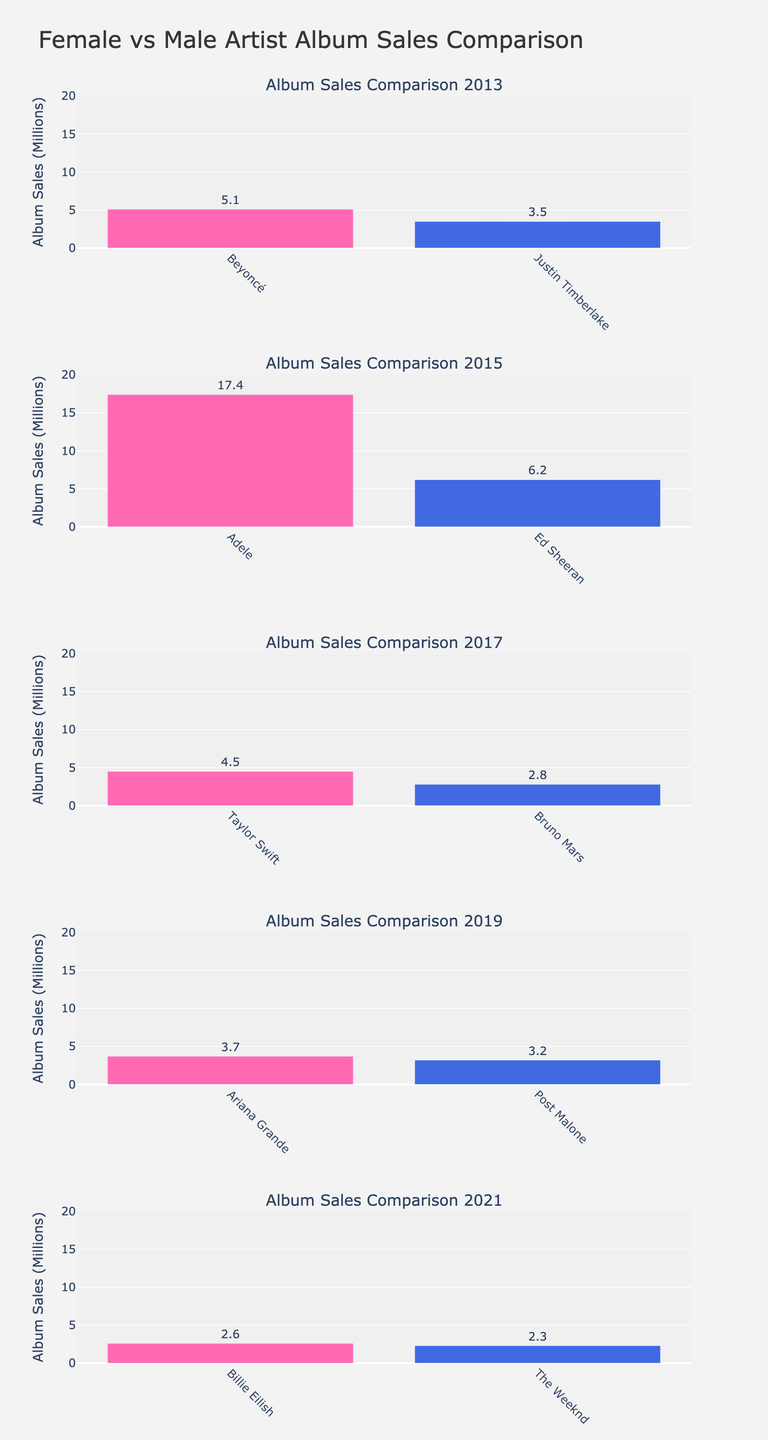Which show has the highest rating in season 1? Look at each subplot representing the different shows and focus on the ratings for season 1. Compare the ratings: "Law & Order" (7.2), "NYPD Blue" (8.0), "The Wire" (8.6), "Hill Street Blues" (7.9), "Blue Bloods" (7.5). "The Wire" has the highest rating in season 1.
Answer: The Wire How does the rating of "Law & Order" change from season 1 to season 20? In the "Law & Order" subplot, check the ratings for season 1 (7.2) and season 20 (7.9) and calculate the difference. The rating increases from 7.2 to 7.9, showing a change of +0.7.
Answer: +0.7 Which show has the most consistent rating across the plotted seasons? Examine the plots and look for the show with the least fluctuation in its ratings. "Blue Bloods" ratings vary between 7.5 and 7.8, while other shows have larger variations.
Answer: Blue Bloods What is the average rating for "NYPD Blue" across the seasons shown? Add the ratings for "NYPD Blue" across all plotted seasons: 8.0 (S1), 8.4 (S4), 8.2 (S8), 7.8 (S12). Then divide by the number of seasons (4): (8.0 + 8.4 + 8.2 + 7.8) / 4 = 8.1.
Answer: 8.1 Which show witnessed the highest peak rating among all the shows, and what was the rating? Look for the highest data point in all subplots. "The Wire" reached a peak rating of 9.2 in season 5.
Answer: The Wire, 9.2 Between "Hill Street Blues" and "Blue Bloods," which show had a higher rating in their respective 5th seasons? Compare the ratings in season 5 for "Hill Street Blues" (8.5) and "Blue Bloods" (7.8). "Hill Street Blues" has a higher rating.
Answer: Hill Street Blues What is the title of the figure? The title is centered at the top of the figure. It reads "Viewer Ratings for Top 5 Police-Themed TV Shows."
Answer: Viewer Ratings for Top 5 Police-Themed TV Shows In which season did "The Wire" experience its lowest rating, and what was the rating? Check the "The Wire" subplot and identify the lowest rating among all seasons: 8.6 in season 1.
Answer: Season 1, 8.6 Which two shows have ratings plotted for fewer than 5 seasons? Observe the number of data points (seasons) in each plot. "The Wire" and "Hill Street Blues" both have fewer than 5 data points.
Answer: The Wire and Hill Street Blues 